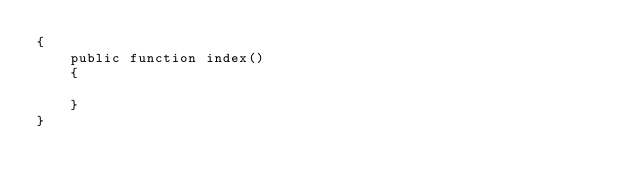<code> <loc_0><loc_0><loc_500><loc_500><_PHP_>{
    public function index()
    {
	
    }
}
</code> 